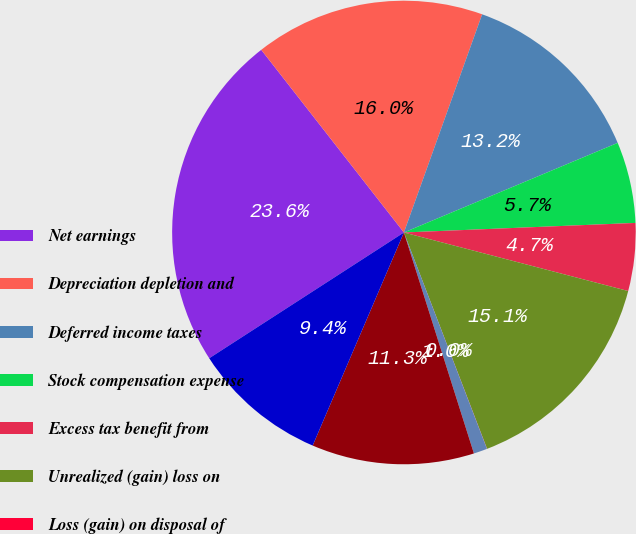Convert chart. <chart><loc_0><loc_0><loc_500><loc_500><pie_chart><fcel>Net earnings<fcel>Depreciation depletion and<fcel>Deferred income taxes<fcel>Stock compensation expense<fcel>Excess tax benefit from<fcel>Unrealized (gain) loss on<fcel>Loss (gain) on disposal of<fcel>Undistributed (earnings) loss<fcel>Accounts receivable<fcel>Margin deposits<nl><fcel>23.57%<fcel>16.03%<fcel>13.2%<fcel>5.66%<fcel>4.72%<fcel>15.09%<fcel>0.01%<fcel>0.95%<fcel>11.32%<fcel>9.43%<nl></chart> 